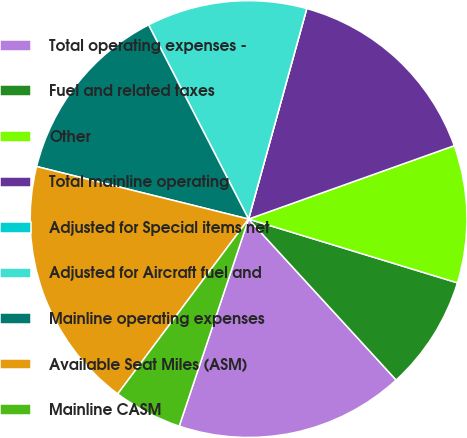Convert chart. <chart><loc_0><loc_0><loc_500><loc_500><pie_chart><fcel>Total operating expenses -<fcel>Fuel and related taxes<fcel>Other<fcel>Total mainline operating<fcel>Adjusted for Special items net<fcel>Adjusted for Aircraft fuel and<fcel>Mainline operating expenses<fcel>Available Seat Miles (ASM)<fcel>Mainline CASM<nl><fcel>16.95%<fcel>8.47%<fcel>10.17%<fcel>15.25%<fcel>0.0%<fcel>11.86%<fcel>13.56%<fcel>18.64%<fcel>5.08%<nl></chart> 